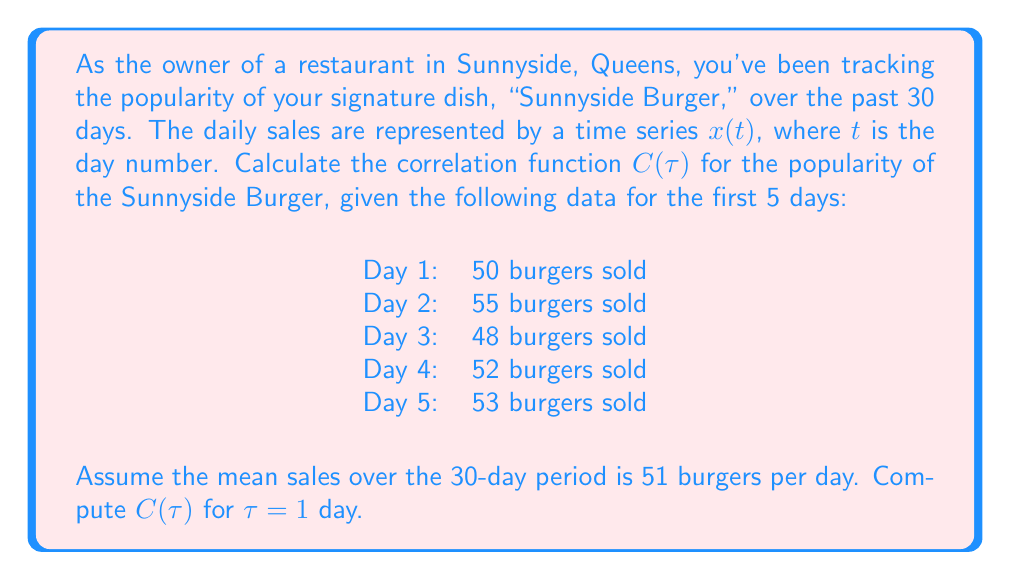Solve this math problem. To solve this problem, we'll follow these steps:

1) The correlation function $C(\tau)$ is defined as:

   $$C(\tau) = \frac{\langle (x(t) - \langle x \rangle)(x(t+\tau) - \langle x \rangle) \rangle}{\langle (x(t) - \langle x \rangle)^2 \rangle}$$

   where $\langle x \rangle$ is the mean value of $x(t)$.

2) We're given that $\langle x \rangle = 51$ burgers per day.

3) First, let's calculate the numerator for $\tau = 1$:

   $$(x(1) - 51)(x(2) - 51) + (x(2) - 51)(x(3) - 51) + (x(3) - 51)(x(4) - 51) + (x(4) - 51)(x(5) - 51)$$
   
   $= (50 - 51)(55 - 51) + (55 - 51)(48 - 51) + (48 - 51)(52 - 51) + (52 - 51)(53 - 51)$
   
   $= (-1)(4) + (4)(-3) + (-3)(1) + (1)(2)$
   
   $= -4 - 12 - 3 + 2 = -17$

4) Now, let's calculate the denominator:

   $$(50 - 51)^2 + (55 - 51)^2 + (48 - 51)^2 + (52 - 51)^2 + (53 - 51)^2$$
   
   $= 1 + 16 + 9 + 1 + 4 = 31$

5) The correlation function for $\tau = 1$ is thus:

   $$C(1) = \frac{-17}{31} \approx -0.5484$$
Answer: $C(1) \approx -0.5484$ 